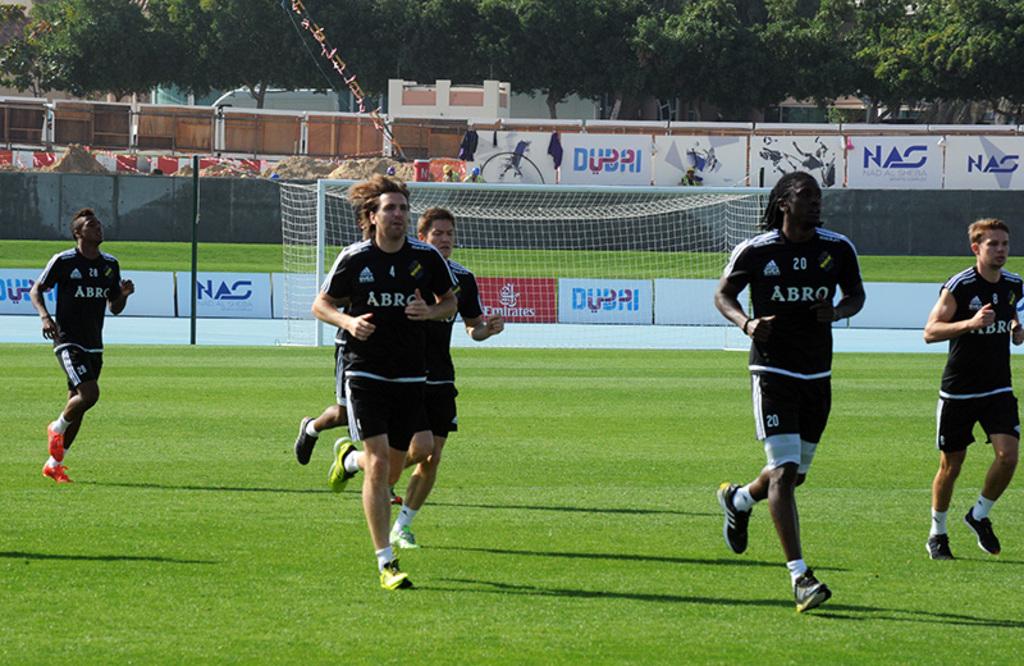What is the name of the sports team?
Ensure brevity in your answer.  Abro. 